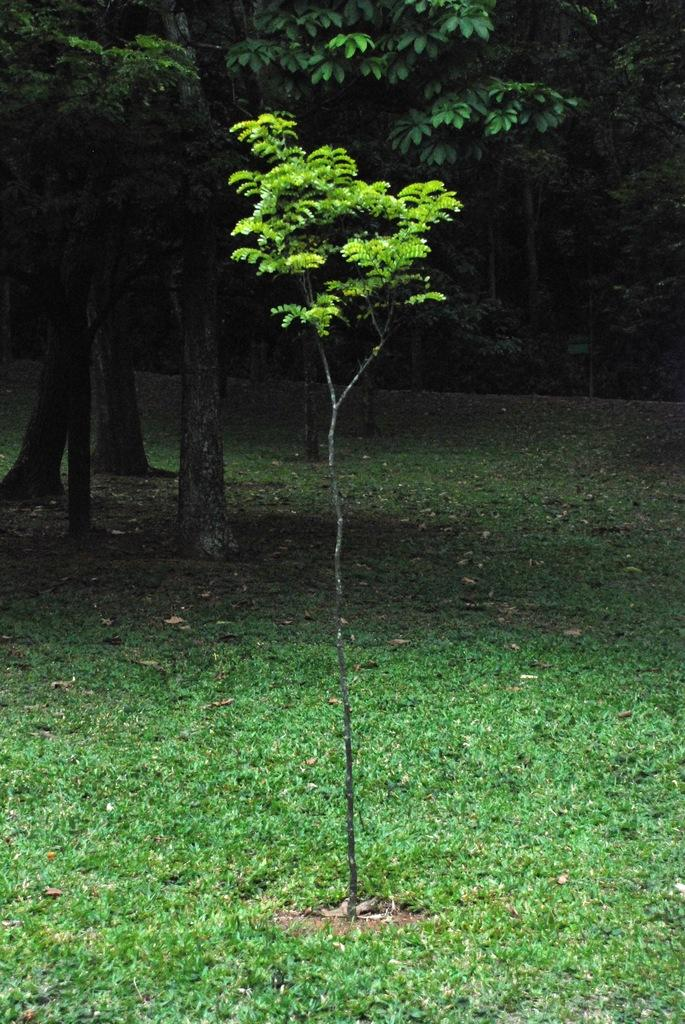What type of vegetation can be seen in the image? There are trees and a plant visible in the image. What is the ground covered with in the image? There is grass visible in the image. What can be found on the ground in the image? There are leaves on the ground in the image. Where is the playground located in the image? There is no playground present in the image. What type of fruit can be seen on the plant in the image? The image does not show any fruit on the plant, only the plant itself. Who is the partner of the plant in the image? Plants do not have partners; they are living organisms that grow and reproduce independently. 